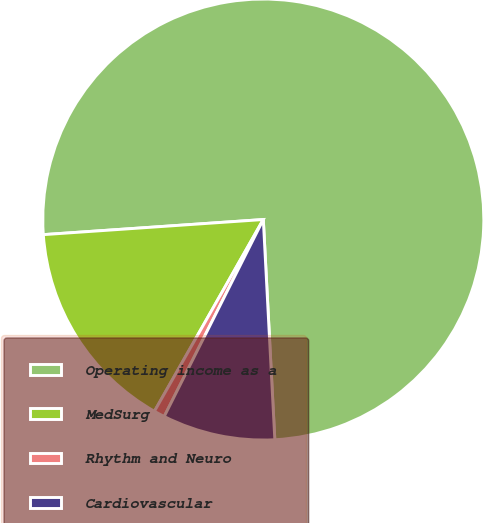Convert chart. <chart><loc_0><loc_0><loc_500><loc_500><pie_chart><fcel>Operating income as a<fcel>MedSurg<fcel>Rhythm and Neuro<fcel>Cardiovascular<nl><fcel>75.26%<fcel>15.69%<fcel>0.8%<fcel>8.25%<nl></chart> 